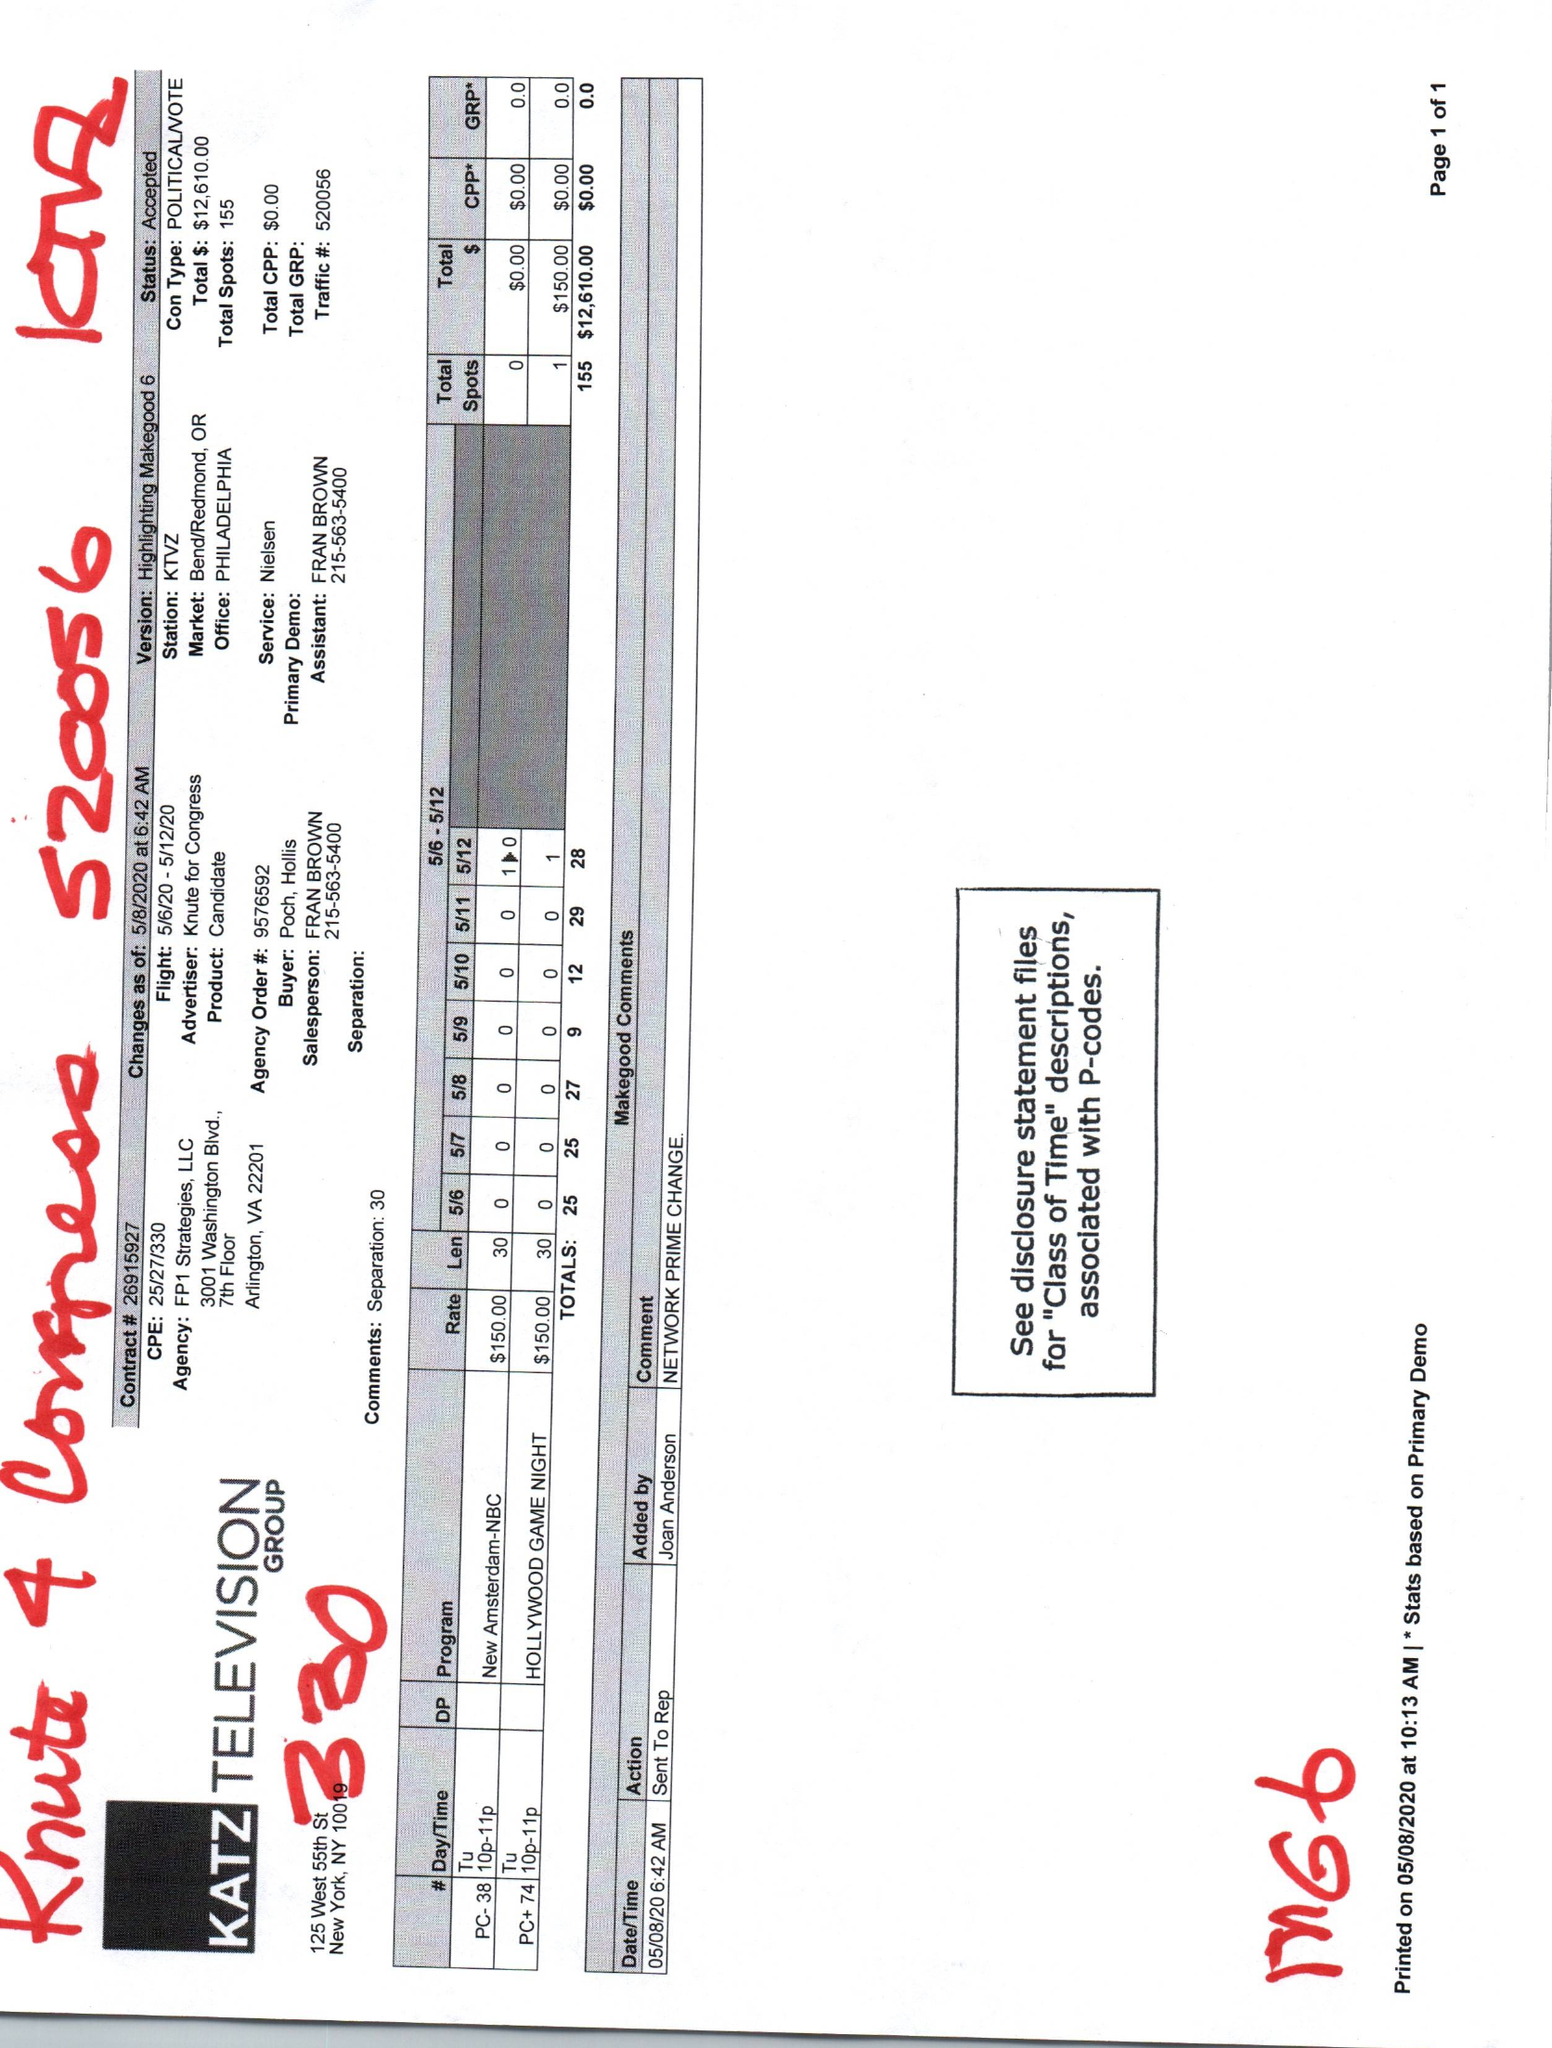What is the value for the contract_num?
Answer the question using a single word or phrase. 26915927 